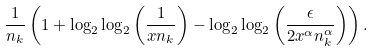Convert formula to latex. <formula><loc_0><loc_0><loc_500><loc_500>\frac { 1 } { n _ { k } } \left ( 1 + \log _ { 2 } \log _ { 2 } \left ( \frac { 1 } { x n _ { k } } \right ) - \log _ { 2 } \log _ { 2 } \left ( \frac { \epsilon } { 2 x ^ { \alpha } n _ { k } ^ { \alpha } } \right ) \right ) .</formula> 